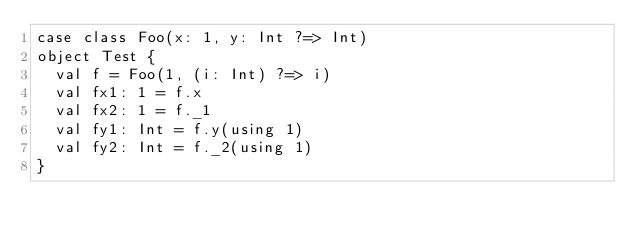<code> <loc_0><loc_0><loc_500><loc_500><_Scala_>case class Foo(x: 1, y: Int ?=> Int)
object Test {
  val f = Foo(1, (i: Int) ?=> i)
  val fx1: 1 = f.x
  val fx2: 1 = f._1
  val fy1: Int = f.y(using 1)
  val fy2: Int = f._2(using 1)
}
</code> 